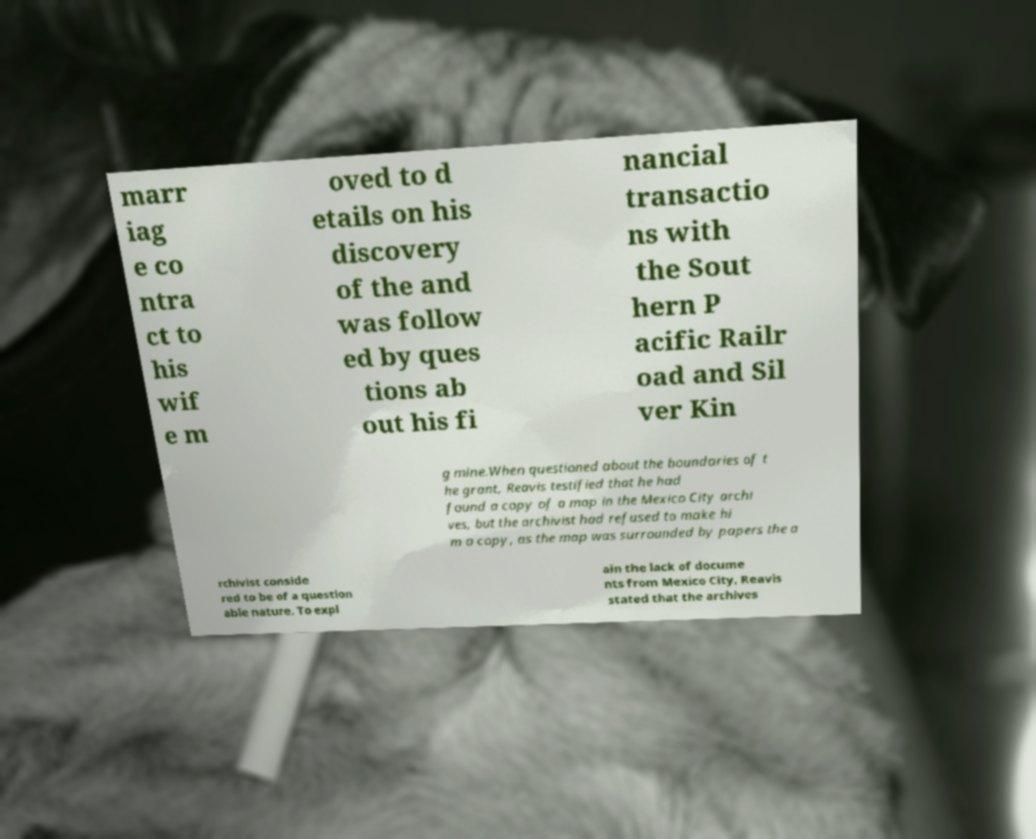Please identify and transcribe the text found in this image. marr iag e co ntra ct to his wif e m oved to d etails on his discovery of the and was follow ed by ques tions ab out his fi nancial transactio ns with the Sout hern P acific Railr oad and Sil ver Kin g mine.When questioned about the boundaries of t he grant, Reavis testified that he had found a copy of a map in the Mexico City archi ves, but the archivist had refused to make hi m a copy, as the map was surrounded by papers the a rchivist conside red to be of a question able nature. To expl ain the lack of docume nts from Mexico City, Reavis stated that the archives 